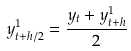<formula> <loc_0><loc_0><loc_500><loc_500>y _ { t + h / 2 } ^ { 1 } = { \frac { y _ { t } + y _ { t + h } ^ { 1 } } { 2 } }</formula> 